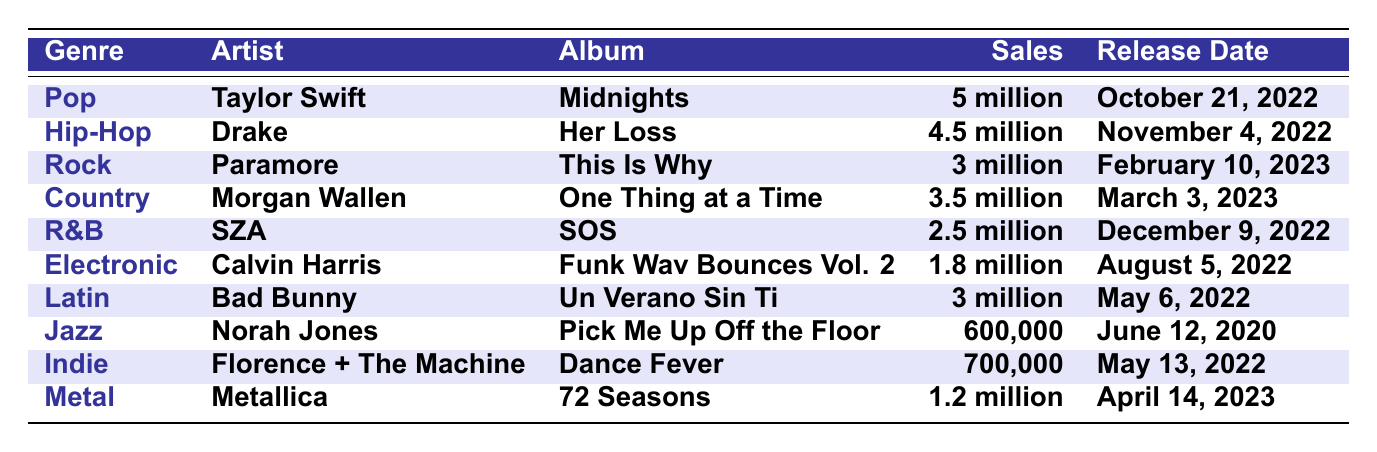What is the best-selling album in the Pop genre? The best-selling album in the Pop genre is "Midnights" by Taylor Swift, which achieved sales of 5 million copies.
Answer: "Midnights" by Taylor Swift Which artist released the album "Her Loss"? The album "Her Loss" was released by Drake, and it falls under the Hip-Hop genre.
Answer: Drake How many albums sold more than 3 million copies? The albums that sold more than 3 million copies are "Midnights" (5 million), "Her Loss" (4.5 million), "One Thing at a Time" (3.5 million), and "This Is Why" (3 million), totaling four albums.
Answer: Four albums Is "SOS" by SZA categorized as Country? "SOS" by SZA is categorized as R&B, not Country. Therefore, the statement is false.
Answer: No What is the total sales of the Rock and Country genres combined? The album "This Is Why" in Rock sold 3 million, and "One Thing at a Time" in Country sold 3.5 million. Adding these gives a total of 6.5 million for both genres combined (3 million + 3.5 million).
Answer: 6.5 million Which genre does "72 Seasons" belong to and what were its sales? "72 Seasons" belongs to the Metal genre and its sales amounted to 1.2 million copies.
Answer: Metal; 1.2 million Who is the artist of the lowest-selling album in the table? The lowest-selling album in the table is "Pick Me Up Off the Floor" by Norah Jones, which sold 600,000 copies.
Answer: Norah Jones What percentage of the total sales of all albums does "Un Verano Sin Ti" represent? The total sales of all albums are 20.7 million (5 + 4.5 + 3 + 3.5 + 2.5 + 1.8 + 3 + 0.6 + 0.7 + 1.2 = 20.7 million). Since "Un Verano Sin Ti" sold 3 million, the percentage is (3/20.7)*100 ≈ 14.49%.
Answer: Approximately 14.49% Which album was released most recently? The most recently released album in the list is "72 Seasons" by Metallica, which had a release date of April 14, 2023.
Answer: "72 Seasons" by Metallica What is the average sales of albums in the R&B and Jazz genres? "SOS" sold 2.5 million in R&B, and "Pick Me Up Off the Floor" sold 600,000 in Jazz. To find the average: (2.5 million + 0.6 million) / 2 = 1.55 million.
Answer: 1.55 million 